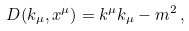<formula> <loc_0><loc_0><loc_500><loc_500>D ( k _ { \mu } , x ^ { \mu } ) = k ^ { \mu } k _ { \mu } - m ^ { 2 } \, ,</formula> 